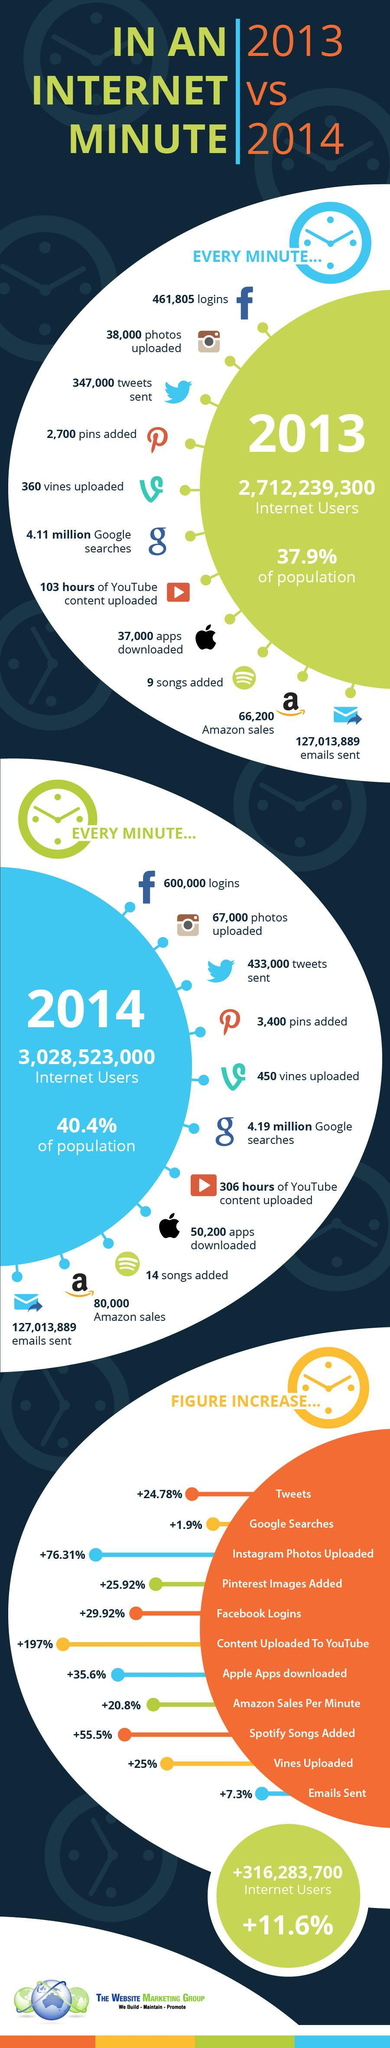Which social media tool has the highest percentage increase in images uploaded?
Answer the question with a short phrase. Instagram What is the increase in the percentage of population using internet by the minute from 2013 to 2014? 2.5% What was the total hours of content uploaded in yotube in the year 2013 and 2014? 409 hours What is the increase in number users using internet every 60 secs from 2013 to 2014? 316,283,700 What is the average sales recorded through Amazon in the period 2013-14? 73,100 What is the rise in the number of pins added every single minute from 2013 to 2014? 700 pins Which digital medium recorded the third highest percentage increase in content added, youtube, spotify, or instagram? Spotify 